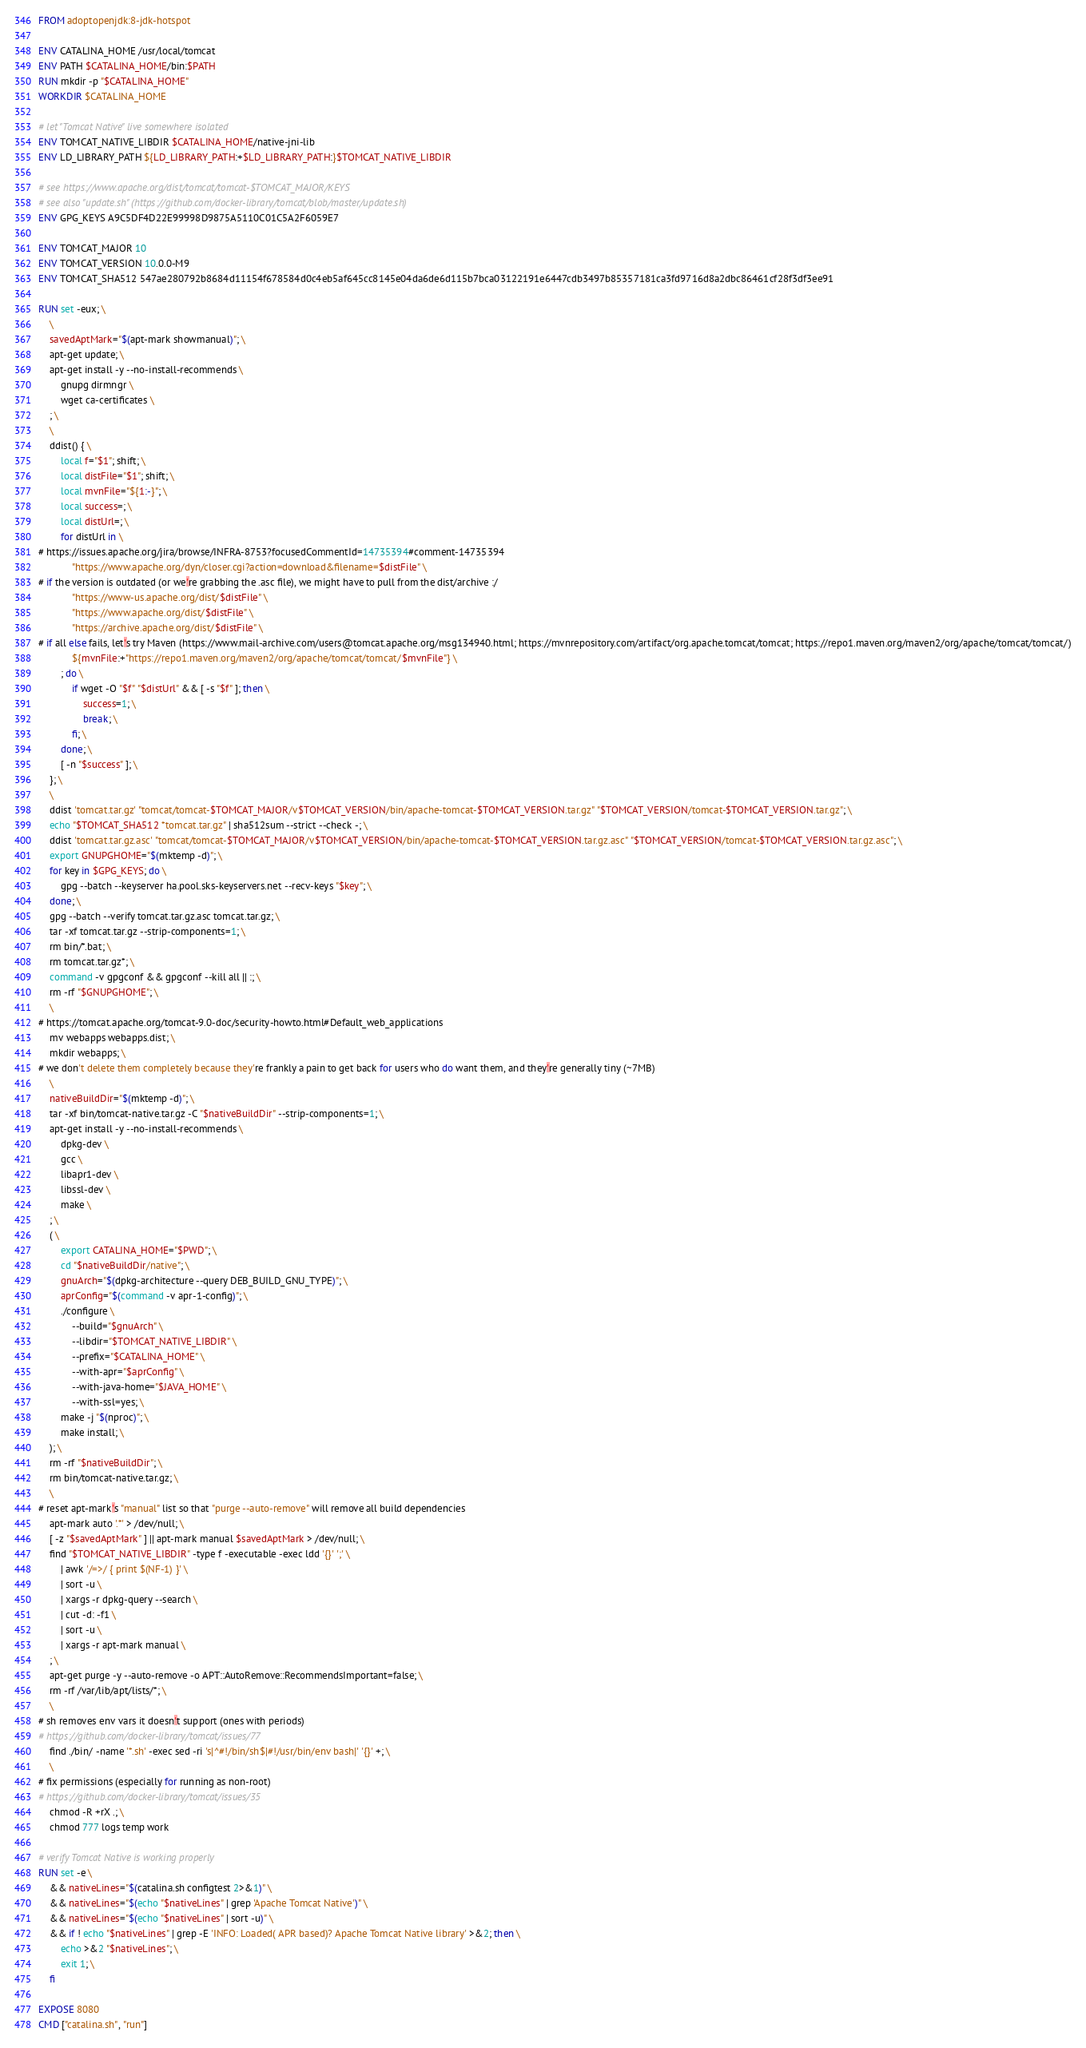<code> <loc_0><loc_0><loc_500><loc_500><_Dockerfile_>FROM adoptopenjdk:8-jdk-hotspot

ENV CATALINA_HOME /usr/local/tomcat
ENV PATH $CATALINA_HOME/bin:$PATH
RUN mkdir -p "$CATALINA_HOME"
WORKDIR $CATALINA_HOME

# let "Tomcat Native" live somewhere isolated
ENV TOMCAT_NATIVE_LIBDIR $CATALINA_HOME/native-jni-lib
ENV LD_LIBRARY_PATH ${LD_LIBRARY_PATH:+$LD_LIBRARY_PATH:}$TOMCAT_NATIVE_LIBDIR

# see https://www.apache.org/dist/tomcat/tomcat-$TOMCAT_MAJOR/KEYS
# see also "update.sh" (https://github.com/docker-library/tomcat/blob/master/update.sh)
ENV GPG_KEYS A9C5DF4D22E99998D9875A5110C01C5A2F6059E7

ENV TOMCAT_MAJOR 10
ENV TOMCAT_VERSION 10.0.0-M9
ENV TOMCAT_SHA512 547ae280792b8684d11154f678584d0c4eb5af645cc8145e04da6de6d115b7bca03122191e6447cdb3497b85357181ca3fd9716d8a2dbc86461cf28f3df3ee91

RUN set -eux; \
	\
	savedAptMark="$(apt-mark showmanual)"; \
	apt-get update; \
	apt-get install -y --no-install-recommends \
		gnupg dirmngr \
		wget ca-certificates \
	; \
	\
	ddist() { \
		local f="$1"; shift; \
		local distFile="$1"; shift; \
		local mvnFile="${1:-}"; \
		local success=; \
		local distUrl=; \
		for distUrl in \
# https://issues.apache.org/jira/browse/INFRA-8753?focusedCommentId=14735394#comment-14735394
			"https://www.apache.org/dyn/closer.cgi?action=download&filename=$distFile" \
# if the version is outdated (or we're grabbing the .asc file), we might have to pull from the dist/archive :/
			"https://www-us.apache.org/dist/$distFile" \
			"https://www.apache.org/dist/$distFile" \
			"https://archive.apache.org/dist/$distFile" \
# if all else fails, let's try Maven (https://www.mail-archive.com/users@tomcat.apache.org/msg134940.html; https://mvnrepository.com/artifact/org.apache.tomcat/tomcat; https://repo1.maven.org/maven2/org/apache/tomcat/tomcat/)
			${mvnFile:+"https://repo1.maven.org/maven2/org/apache/tomcat/tomcat/$mvnFile"} \
		; do \
			if wget -O "$f" "$distUrl" && [ -s "$f" ]; then \
				success=1; \
				break; \
			fi; \
		done; \
		[ -n "$success" ]; \
	}; \
	\
	ddist 'tomcat.tar.gz' "tomcat/tomcat-$TOMCAT_MAJOR/v$TOMCAT_VERSION/bin/apache-tomcat-$TOMCAT_VERSION.tar.gz" "$TOMCAT_VERSION/tomcat-$TOMCAT_VERSION.tar.gz"; \
	echo "$TOMCAT_SHA512 *tomcat.tar.gz" | sha512sum --strict --check -; \
	ddist 'tomcat.tar.gz.asc' "tomcat/tomcat-$TOMCAT_MAJOR/v$TOMCAT_VERSION/bin/apache-tomcat-$TOMCAT_VERSION.tar.gz.asc" "$TOMCAT_VERSION/tomcat-$TOMCAT_VERSION.tar.gz.asc"; \
	export GNUPGHOME="$(mktemp -d)"; \
	for key in $GPG_KEYS; do \
		gpg --batch --keyserver ha.pool.sks-keyservers.net --recv-keys "$key"; \
	done; \
	gpg --batch --verify tomcat.tar.gz.asc tomcat.tar.gz; \
	tar -xf tomcat.tar.gz --strip-components=1; \
	rm bin/*.bat; \
	rm tomcat.tar.gz*; \
	command -v gpgconf && gpgconf --kill all || :; \
	rm -rf "$GNUPGHOME"; \
	\
# https://tomcat.apache.org/tomcat-9.0-doc/security-howto.html#Default_web_applications
	mv webapps webapps.dist; \
	mkdir webapps; \
# we don't delete them completely because they're frankly a pain to get back for users who do want them, and they're generally tiny (~7MB)
	\
	nativeBuildDir="$(mktemp -d)"; \
	tar -xf bin/tomcat-native.tar.gz -C "$nativeBuildDir" --strip-components=1; \
	apt-get install -y --no-install-recommends \
		dpkg-dev \
		gcc \
		libapr1-dev \
		libssl-dev \
		make \
	; \
	( \
		export CATALINA_HOME="$PWD"; \
		cd "$nativeBuildDir/native"; \
		gnuArch="$(dpkg-architecture --query DEB_BUILD_GNU_TYPE)"; \
		aprConfig="$(command -v apr-1-config)"; \
		./configure \
			--build="$gnuArch" \
			--libdir="$TOMCAT_NATIVE_LIBDIR" \
			--prefix="$CATALINA_HOME" \
			--with-apr="$aprConfig" \
			--with-java-home="$JAVA_HOME" \
			--with-ssl=yes; \
		make -j "$(nproc)"; \
		make install; \
	); \
	rm -rf "$nativeBuildDir"; \
	rm bin/tomcat-native.tar.gz; \
	\
# reset apt-mark's "manual" list so that "purge --auto-remove" will remove all build dependencies
	apt-mark auto '.*' > /dev/null; \
	[ -z "$savedAptMark" ] || apt-mark manual $savedAptMark > /dev/null; \
	find "$TOMCAT_NATIVE_LIBDIR" -type f -executable -exec ldd '{}' ';' \
		| awk '/=>/ { print $(NF-1) }' \
		| sort -u \
		| xargs -r dpkg-query --search \
		| cut -d: -f1 \
		| sort -u \
		| xargs -r apt-mark manual \
	; \
	apt-get purge -y --auto-remove -o APT::AutoRemove::RecommendsImportant=false; \
	rm -rf /var/lib/apt/lists/*; \
	\
# sh removes env vars it doesn't support (ones with periods)
# https://github.com/docker-library/tomcat/issues/77
	find ./bin/ -name '*.sh' -exec sed -ri 's|^#!/bin/sh$|#!/usr/bin/env bash|' '{}' +; \
	\
# fix permissions (especially for running as non-root)
# https://github.com/docker-library/tomcat/issues/35
	chmod -R +rX .; \
	chmod 777 logs temp work

# verify Tomcat Native is working properly
RUN set -e \
	&& nativeLines="$(catalina.sh configtest 2>&1)" \
	&& nativeLines="$(echo "$nativeLines" | grep 'Apache Tomcat Native')" \
	&& nativeLines="$(echo "$nativeLines" | sort -u)" \
	&& if ! echo "$nativeLines" | grep -E 'INFO: Loaded( APR based)? Apache Tomcat Native library' >&2; then \
		echo >&2 "$nativeLines"; \
		exit 1; \
	fi

EXPOSE 8080
CMD ["catalina.sh", "run"]
</code> 